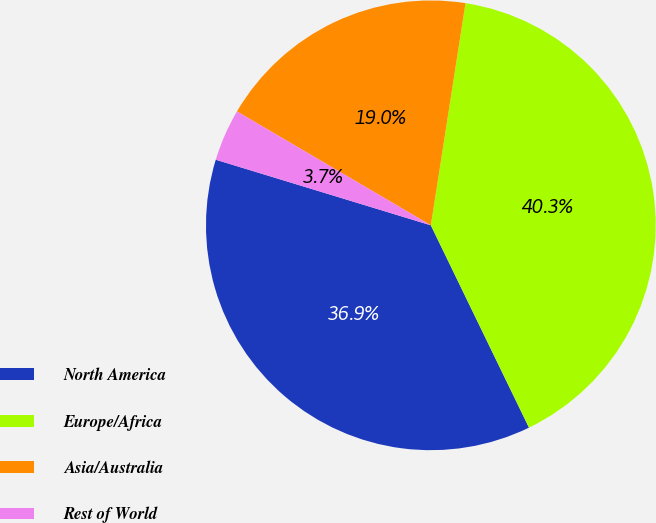Convert chart to OTSL. <chart><loc_0><loc_0><loc_500><loc_500><pie_chart><fcel>North America<fcel>Europe/Africa<fcel>Asia/Australia<fcel>Rest of World<nl><fcel>36.9%<fcel>40.35%<fcel>19.01%<fcel>3.74%<nl></chart> 